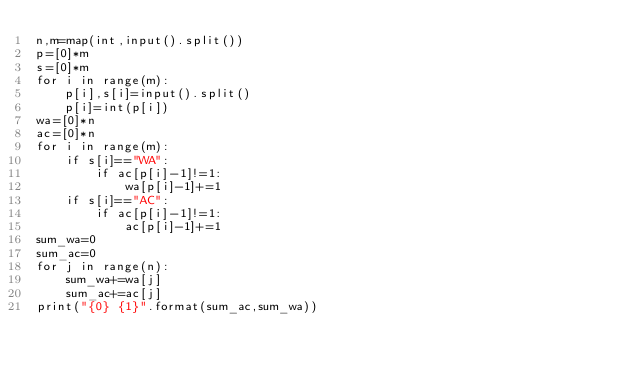Convert code to text. <code><loc_0><loc_0><loc_500><loc_500><_Python_>n,m=map(int,input().split())
p=[0]*m
s=[0]*m
for i in range(m):
    p[i],s[i]=input().split()
    p[i]=int(p[i])
wa=[0]*n
ac=[0]*n
for i in range(m):
    if s[i]=="WA":
        if ac[p[i]-1]!=1:
            wa[p[i]-1]+=1
    if s[i]=="AC":
        if ac[p[i]-1]!=1:
            ac[p[i]-1]+=1
sum_wa=0
sum_ac=0
for j in range(n):
    sum_wa+=wa[j]
    sum_ac+=ac[j]
print("{0} {1}".format(sum_ac,sum_wa))
</code> 